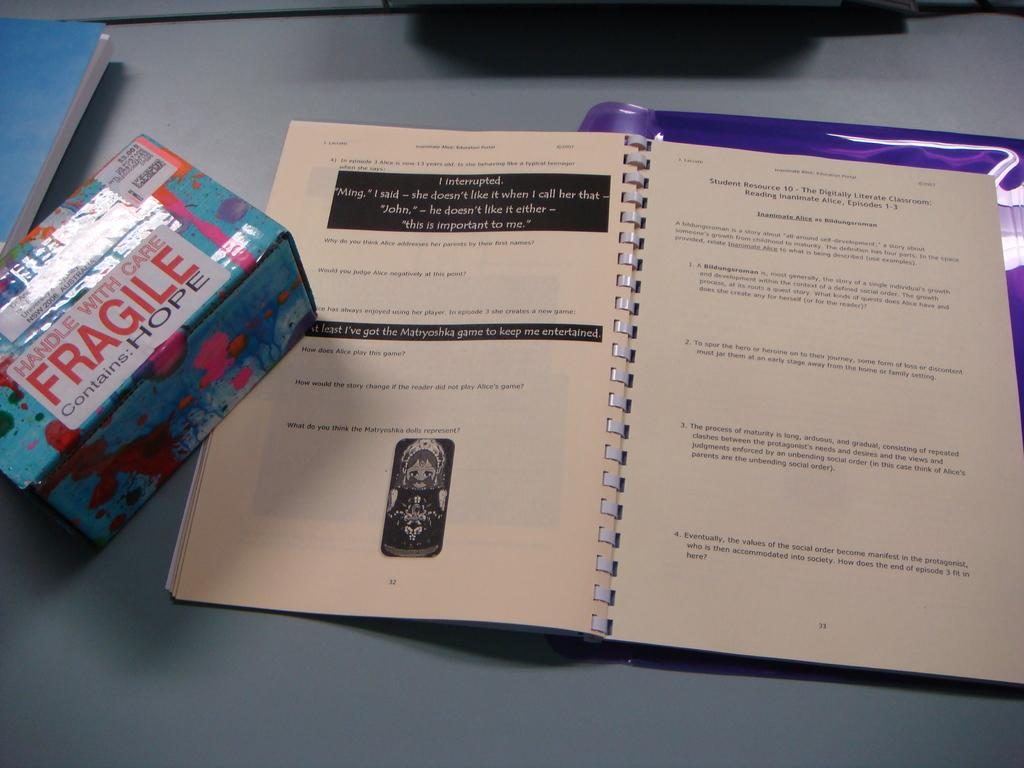What objects are on the table in the image? There are books and a box on the table. Can you describe the books on the table? The books on the table are likely for reading or reference purposes. What else can be seen on the table besides the books? There is a box on the table. What flavor of humor is depicted in the image? There is no humor depicted in the image; it features books and a box on a table. 